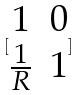<formula> <loc_0><loc_0><loc_500><loc_500>[ \begin{matrix} 1 & 0 \\ \frac { 1 } { R } & 1 \end{matrix} ]</formula> 